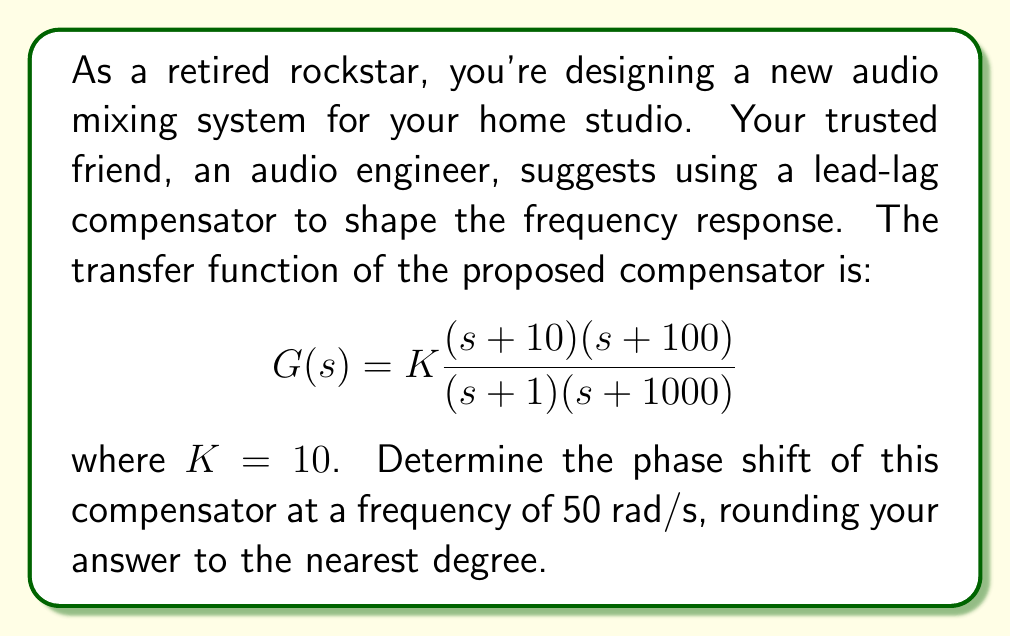Show me your answer to this math problem. To analyze the frequency response of the lead-lag compensator, we'll follow these steps:

1) The transfer function is given as:
   $$G(s) = 10 \frac{(s + 10)(s + 100)}{(s + 1)(s + 1000)}$$

2) To find the phase shift at $\omega = 50$ rad/s, we need to substitute $s = j\omega = j50$ into the transfer function:
   $$G(j50) = 10 \frac{(j50 + 10)(j50 + 100)}{(j50 + 1)(j50 + 1000)}$$

3) Let's break this down into four parts:
   $\angle(j50 + 10) = \tan^{-1}(50/10) = 78.69°$
   $\angle(j50 + 100) = \tan^{-1}(50/100) = 26.57°$
   $\angle(j50 + 1) = \tan^{-1}(50/1) = 88.85°$
   $\angle(j50 + 1000) = \tan^{-1}(50/1000) = 2.86°$

4) The total phase shift is the sum of the angles in the numerator minus the sum of the angles in the denominator:
   $\phi = (78.69° + 26.57°) - (88.85° + 2.86°) = 13.55°$

5) Rounding to the nearest degree:
   $\phi \approx 14°$
Answer: 14° 